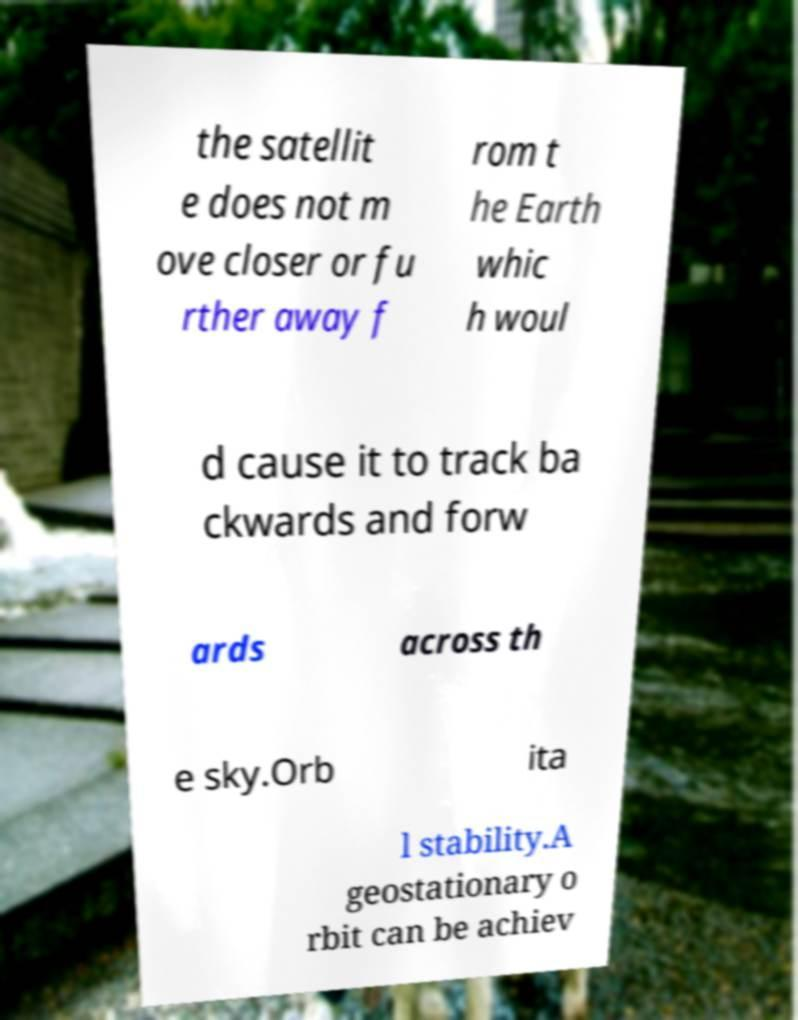Could you assist in decoding the text presented in this image and type it out clearly? the satellit e does not m ove closer or fu rther away f rom t he Earth whic h woul d cause it to track ba ckwards and forw ards across th e sky.Orb ita l stability.A geostationary o rbit can be achiev 